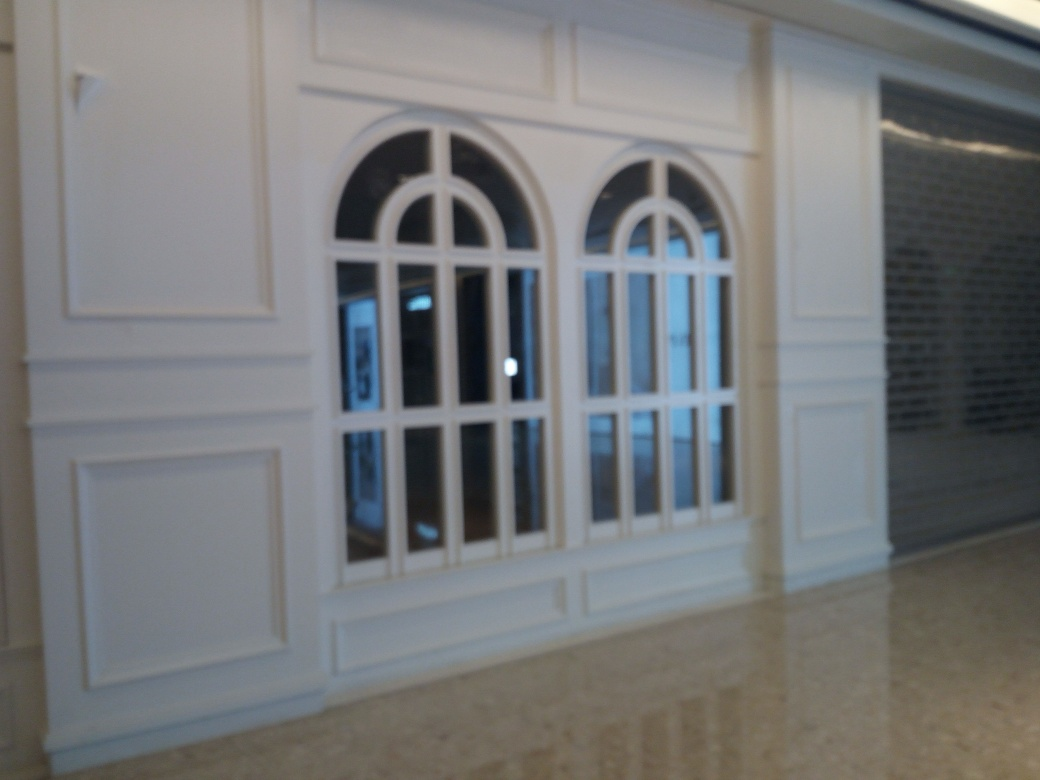What can be inferred about the building this photo was taken in? From the ornate windows and the polished floor, it can be inferred that this photograph was taken inside a building with a classical or formal aesthetic, perhaps a public building, hotel, or high-end residential property. 